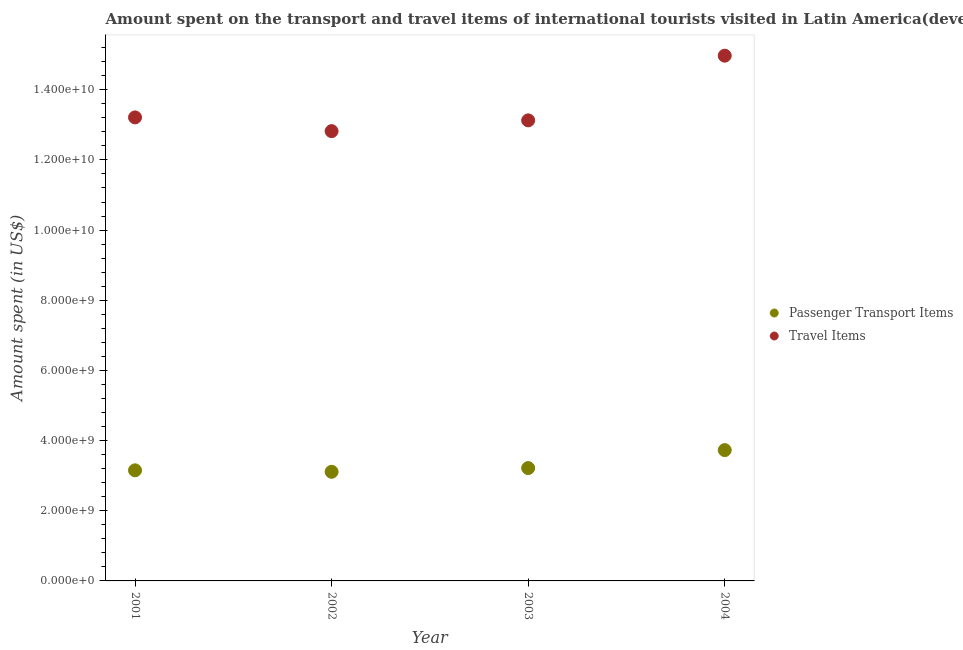How many different coloured dotlines are there?
Make the answer very short. 2. Is the number of dotlines equal to the number of legend labels?
Your response must be concise. Yes. What is the amount spent in travel items in 2004?
Provide a succinct answer. 1.50e+1. Across all years, what is the maximum amount spent on passenger transport items?
Provide a succinct answer. 3.73e+09. Across all years, what is the minimum amount spent on passenger transport items?
Make the answer very short. 3.11e+09. In which year was the amount spent on passenger transport items maximum?
Provide a short and direct response. 2004. In which year was the amount spent in travel items minimum?
Make the answer very short. 2002. What is the total amount spent in travel items in the graph?
Ensure brevity in your answer.  5.41e+1. What is the difference between the amount spent in travel items in 2003 and that in 2004?
Your answer should be very brief. -1.84e+09. What is the difference between the amount spent in travel items in 2003 and the amount spent on passenger transport items in 2002?
Give a very brief answer. 1.00e+1. What is the average amount spent in travel items per year?
Ensure brevity in your answer.  1.35e+1. In the year 2004, what is the difference between the amount spent on passenger transport items and amount spent in travel items?
Give a very brief answer. -1.12e+1. In how many years, is the amount spent in travel items greater than 13200000000 US$?
Your answer should be compact. 2. What is the ratio of the amount spent on passenger transport items in 2002 to that in 2003?
Your response must be concise. 0.97. Is the difference between the amount spent on passenger transport items in 2003 and 2004 greater than the difference between the amount spent in travel items in 2003 and 2004?
Provide a succinct answer. Yes. What is the difference between the highest and the second highest amount spent in travel items?
Make the answer very short. 1.76e+09. What is the difference between the highest and the lowest amount spent on passenger transport items?
Keep it short and to the point. 6.18e+08. Is the amount spent on passenger transport items strictly less than the amount spent in travel items over the years?
Your answer should be compact. Yes. What is the difference between two consecutive major ticks on the Y-axis?
Offer a very short reply. 2.00e+09. Does the graph contain any zero values?
Your response must be concise. No. Does the graph contain grids?
Your response must be concise. No. What is the title of the graph?
Give a very brief answer. Amount spent on the transport and travel items of international tourists visited in Latin America(developing only). Does "Young" appear as one of the legend labels in the graph?
Offer a very short reply. No. What is the label or title of the X-axis?
Provide a succinct answer. Year. What is the label or title of the Y-axis?
Your response must be concise. Amount spent (in US$). What is the Amount spent (in US$) in Passenger Transport Items in 2001?
Keep it short and to the point. 3.15e+09. What is the Amount spent (in US$) of Travel Items in 2001?
Provide a succinct answer. 1.32e+1. What is the Amount spent (in US$) of Passenger Transport Items in 2002?
Give a very brief answer. 3.11e+09. What is the Amount spent (in US$) of Travel Items in 2002?
Offer a very short reply. 1.28e+1. What is the Amount spent (in US$) of Passenger Transport Items in 2003?
Offer a terse response. 3.22e+09. What is the Amount spent (in US$) of Travel Items in 2003?
Your answer should be compact. 1.31e+1. What is the Amount spent (in US$) of Passenger Transport Items in 2004?
Your answer should be compact. 3.73e+09. What is the Amount spent (in US$) in Travel Items in 2004?
Make the answer very short. 1.50e+1. Across all years, what is the maximum Amount spent (in US$) of Passenger Transport Items?
Your response must be concise. 3.73e+09. Across all years, what is the maximum Amount spent (in US$) of Travel Items?
Offer a terse response. 1.50e+1. Across all years, what is the minimum Amount spent (in US$) of Passenger Transport Items?
Give a very brief answer. 3.11e+09. Across all years, what is the minimum Amount spent (in US$) of Travel Items?
Provide a short and direct response. 1.28e+1. What is the total Amount spent (in US$) in Passenger Transport Items in the graph?
Your answer should be very brief. 1.32e+1. What is the total Amount spent (in US$) in Travel Items in the graph?
Your response must be concise. 5.41e+1. What is the difference between the Amount spent (in US$) of Passenger Transport Items in 2001 and that in 2002?
Provide a succinct answer. 4.19e+07. What is the difference between the Amount spent (in US$) of Travel Items in 2001 and that in 2002?
Offer a very short reply. 3.91e+08. What is the difference between the Amount spent (in US$) of Passenger Transport Items in 2001 and that in 2003?
Your answer should be very brief. -6.44e+07. What is the difference between the Amount spent (in US$) of Travel Items in 2001 and that in 2003?
Your response must be concise. 8.46e+07. What is the difference between the Amount spent (in US$) of Passenger Transport Items in 2001 and that in 2004?
Ensure brevity in your answer.  -5.76e+08. What is the difference between the Amount spent (in US$) of Travel Items in 2001 and that in 2004?
Your answer should be very brief. -1.76e+09. What is the difference between the Amount spent (in US$) of Passenger Transport Items in 2002 and that in 2003?
Give a very brief answer. -1.06e+08. What is the difference between the Amount spent (in US$) of Travel Items in 2002 and that in 2003?
Provide a short and direct response. -3.07e+08. What is the difference between the Amount spent (in US$) of Passenger Transport Items in 2002 and that in 2004?
Offer a very short reply. -6.18e+08. What is the difference between the Amount spent (in US$) of Travel Items in 2002 and that in 2004?
Offer a very short reply. -2.15e+09. What is the difference between the Amount spent (in US$) of Passenger Transport Items in 2003 and that in 2004?
Provide a short and direct response. -5.12e+08. What is the difference between the Amount spent (in US$) in Travel Items in 2003 and that in 2004?
Give a very brief answer. -1.84e+09. What is the difference between the Amount spent (in US$) of Passenger Transport Items in 2001 and the Amount spent (in US$) of Travel Items in 2002?
Offer a very short reply. -9.67e+09. What is the difference between the Amount spent (in US$) of Passenger Transport Items in 2001 and the Amount spent (in US$) of Travel Items in 2003?
Your answer should be compact. -9.97e+09. What is the difference between the Amount spent (in US$) in Passenger Transport Items in 2001 and the Amount spent (in US$) in Travel Items in 2004?
Give a very brief answer. -1.18e+1. What is the difference between the Amount spent (in US$) of Passenger Transport Items in 2002 and the Amount spent (in US$) of Travel Items in 2003?
Provide a short and direct response. -1.00e+1. What is the difference between the Amount spent (in US$) of Passenger Transport Items in 2002 and the Amount spent (in US$) of Travel Items in 2004?
Make the answer very short. -1.19e+1. What is the difference between the Amount spent (in US$) of Passenger Transport Items in 2003 and the Amount spent (in US$) of Travel Items in 2004?
Provide a short and direct response. -1.18e+1. What is the average Amount spent (in US$) in Passenger Transport Items per year?
Offer a very short reply. 3.30e+09. What is the average Amount spent (in US$) of Travel Items per year?
Your answer should be very brief. 1.35e+1. In the year 2001, what is the difference between the Amount spent (in US$) of Passenger Transport Items and Amount spent (in US$) of Travel Items?
Your answer should be very brief. -1.01e+1. In the year 2002, what is the difference between the Amount spent (in US$) in Passenger Transport Items and Amount spent (in US$) in Travel Items?
Provide a succinct answer. -9.71e+09. In the year 2003, what is the difference between the Amount spent (in US$) of Passenger Transport Items and Amount spent (in US$) of Travel Items?
Offer a terse response. -9.91e+09. In the year 2004, what is the difference between the Amount spent (in US$) of Passenger Transport Items and Amount spent (in US$) of Travel Items?
Keep it short and to the point. -1.12e+1. What is the ratio of the Amount spent (in US$) in Passenger Transport Items in 2001 to that in 2002?
Provide a short and direct response. 1.01. What is the ratio of the Amount spent (in US$) of Travel Items in 2001 to that in 2002?
Keep it short and to the point. 1.03. What is the ratio of the Amount spent (in US$) of Passenger Transport Items in 2001 to that in 2003?
Your answer should be very brief. 0.98. What is the ratio of the Amount spent (in US$) in Travel Items in 2001 to that in 2003?
Ensure brevity in your answer.  1.01. What is the ratio of the Amount spent (in US$) in Passenger Transport Items in 2001 to that in 2004?
Your answer should be compact. 0.85. What is the ratio of the Amount spent (in US$) of Travel Items in 2001 to that in 2004?
Ensure brevity in your answer.  0.88. What is the ratio of the Amount spent (in US$) of Passenger Transport Items in 2002 to that in 2003?
Give a very brief answer. 0.97. What is the ratio of the Amount spent (in US$) of Travel Items in 2002 to that in 2003?
Give a very brief answer. 0.98. What is the ratio of the Amount spent (in US$) of Passenger Transport Items in 2002 to that in 2004?
Your response must be concise. 0.83. What is the ratio of the Amount spent (in US$) of Travel Items in 2002 to that in 2004?
Your answer should be very brief. 0.86. What is the ratio of the Amount spent (in US$) in Passenger Transport Items in 2003 to that in 2004?
Keep it short and to the point. 0.86. What is the ratio of the Amount spent (in US$) in Travel Items in 2003 to that in 2004?
Provide a short and direct response. 0.88. What is the difference between the highest and the second highest Amount spent (in US$) of Passenger Transport Items?
Your response must be concise. 5.12e+08. What is the difference between the highest and the second highest Amount spent (in US$) in Travel Items?
Keep it short and to the point. 1.76e+09. What is the difference between the highest and the lowest Amount spent (in US$) of Passenger Transport Items?
Your answer should be compact. 6.18e+08. What is the difference between the highest and the lowest Amount spent (in US$) in Travel Items?
Your answer should be very brief. 2.15e+09. 